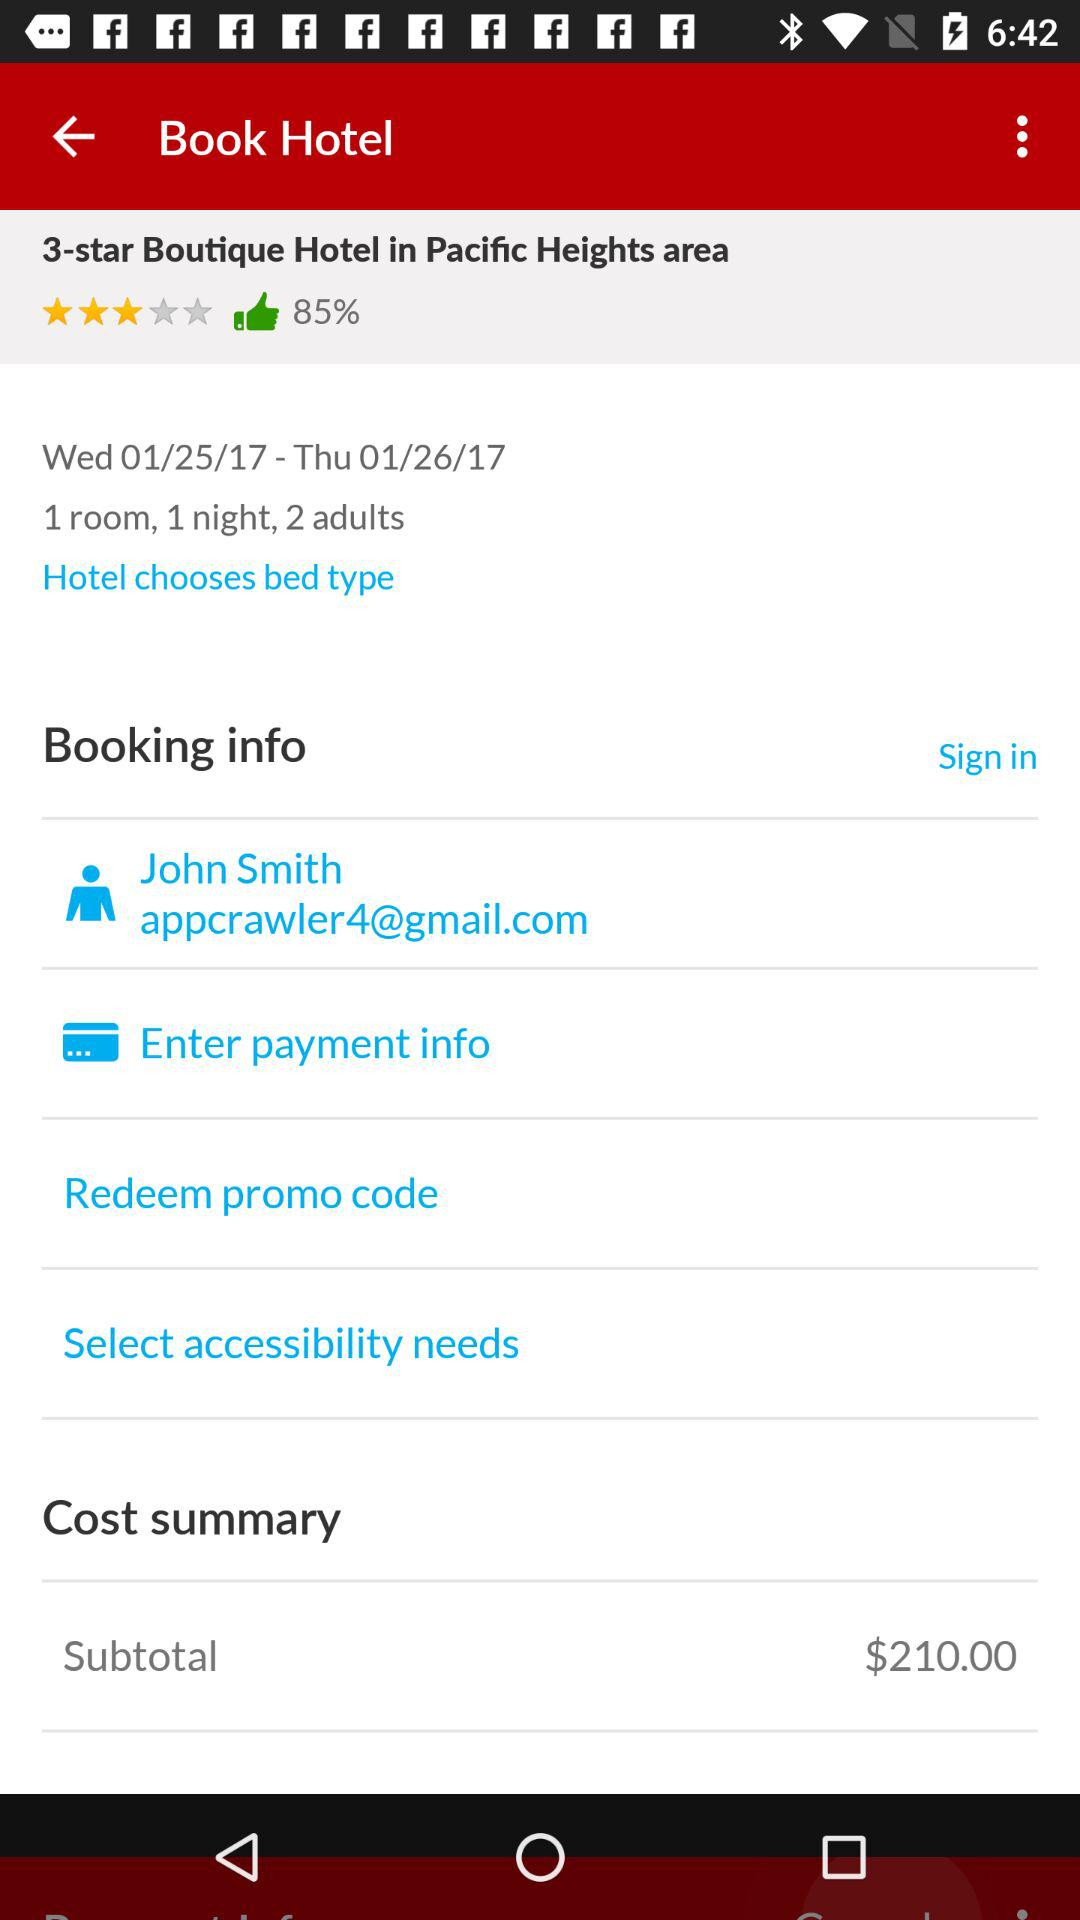How many days is this booking for?
Answer the question using a single word or phrase. 1 